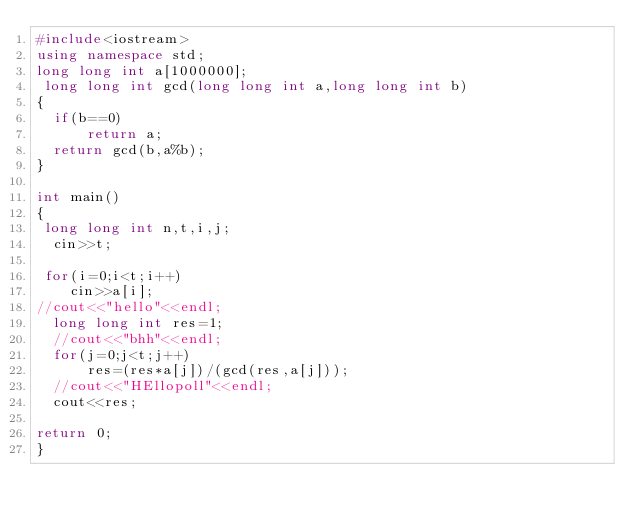Convert code to text. <code><loc_0><loc_0><loc_500><loc_500><_C++_>#include<iostream>
using namespace std;
long long int a[1000000];
 long long int gcd(long long int a,long long int b)
{
	if(b==0)
      return a;
  return gcd(b,a%b);
}

int main()
{
 long long int n,t,i,j;
  cin>>t;

 for(i=0;i<t;i++)
    cin>>a[i];
//cout<<"hello"<<endl;
  long long int res=1;
  //cout<<"bhh"<<endl;
  for(j=0;j<t;j++)
    	res=(res*a[j])/(gcd(res,a[j]));
  //cout<<"HEllopoll"<<endl;
  cout<<res;

return 0;
}
</code> 